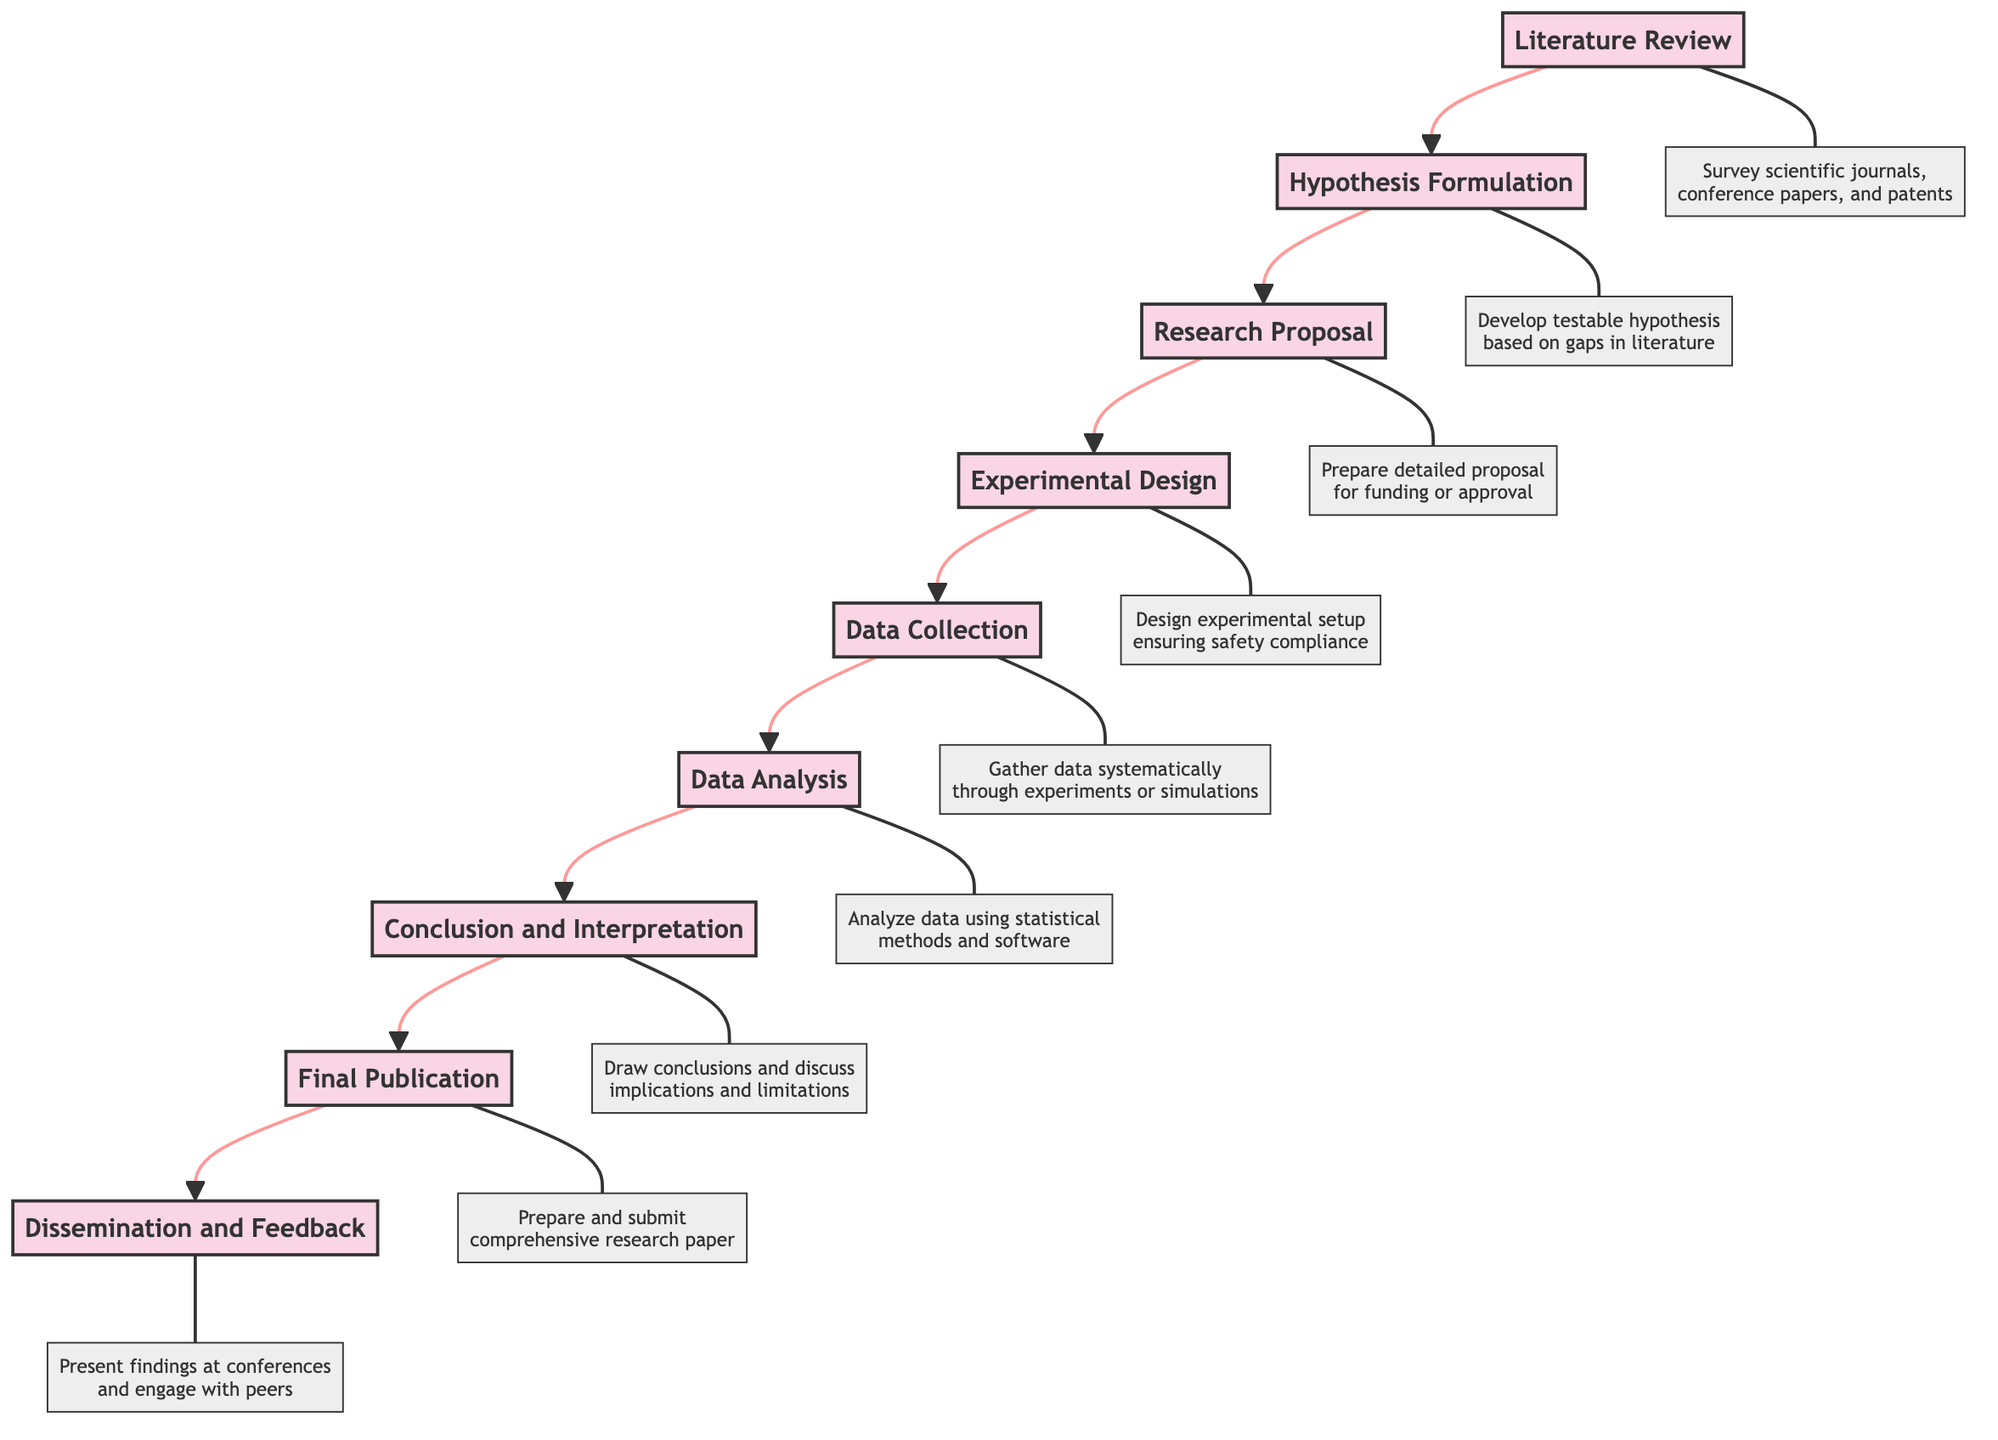What is the first stage of the progression? The diagram starts with the first stage labeled "Literature Review." By looking at the bottom of the flow chart, we see that this is the initial node of the sequence of stages.
Answer: Literature Review How many stages are depicted in the diagram? There are a total of eight stages represented in the flow chart. By counting each node from Literature Review to Dissemination and Feedback, we arrive at the total count.
Answer: Eight What is the relationship between "Hypothesis Formulation" and "Research Proposal"? "Hypothesis Formulation" leads into "Research Proposal" as indicated by the arrow pointing up. This means that the second stage is dependent on the first stage's outcomes.
Answer: Hypothesis Formulation leads to Research Proposal Which stage follows "Data Collection"? The stage that directly comes after "Data Collection" as indicated by the flow of arrows pointing upwards is "Data Analysis." This indicates a sequential progression in the research project.
Answer: Data Analysis Which two stages are directly before "Final Publication"? The two stages that immediately precede "Final Publication" are "Conclusion and Interpretation" and "Data Analysis." The arrows indicate these are the last two steps leading to the final publication of research findings.
Answer: Conclusion and Interpretation, Data Analysis What type of analysis is utilized in the "Data Analysis" stage? The "Data Analysis" stage involves using statistical methods, models, and software for analyzing the data. This is specifically described in the details associated with that stage.
Answer: Statistical methods After preparing the "Research Proposal," what is the next action taken? The next action after preparing the "Research Proposal" is the "Experimental Design." This follows logically in the diagram as part of the progression steps in the research project.
Answer: Experimental Design What does the "Dissemination and Feedback" stage entail? The "Dissemination and Feedback" stage involves presenting findings at academic conferences, workshops, or seminars and engaging with peers for their feedback. It is the final node indicating the sharing of research results.
Answer: Presenting findings at conferences In what direction does the flow of the chart progress? The flow of the chart progresses from the bottom to the top, indicating a sequential development of stages in an engineering research project. This is indicated by arrows pointing upwards throughout the diagram.
Answer: Upwards 